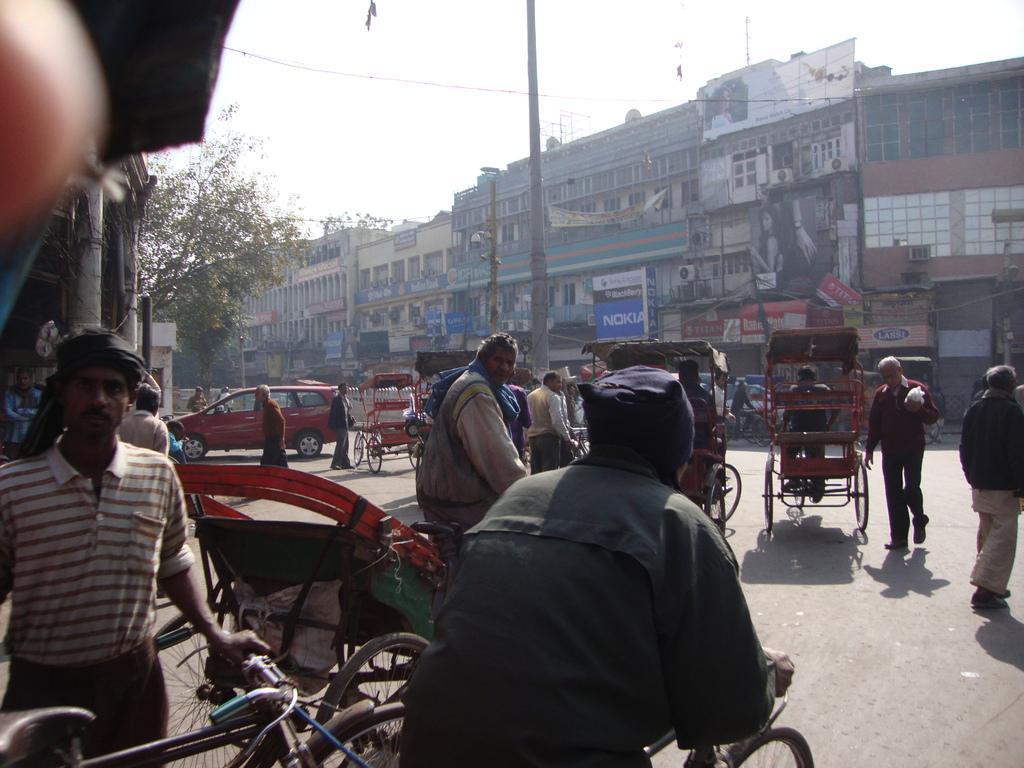Can you describe this image briefly? It is a outside view. There are few peoples are riding a vehicle. The background, we can see buildings. Left side, we can see tree, sky. There is a pole in the center. 